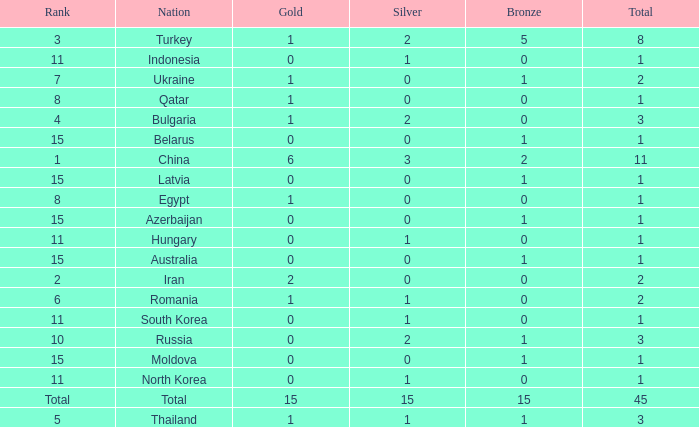What is the sum of the bronze medals of the nation with less than 0 silvers? None. 